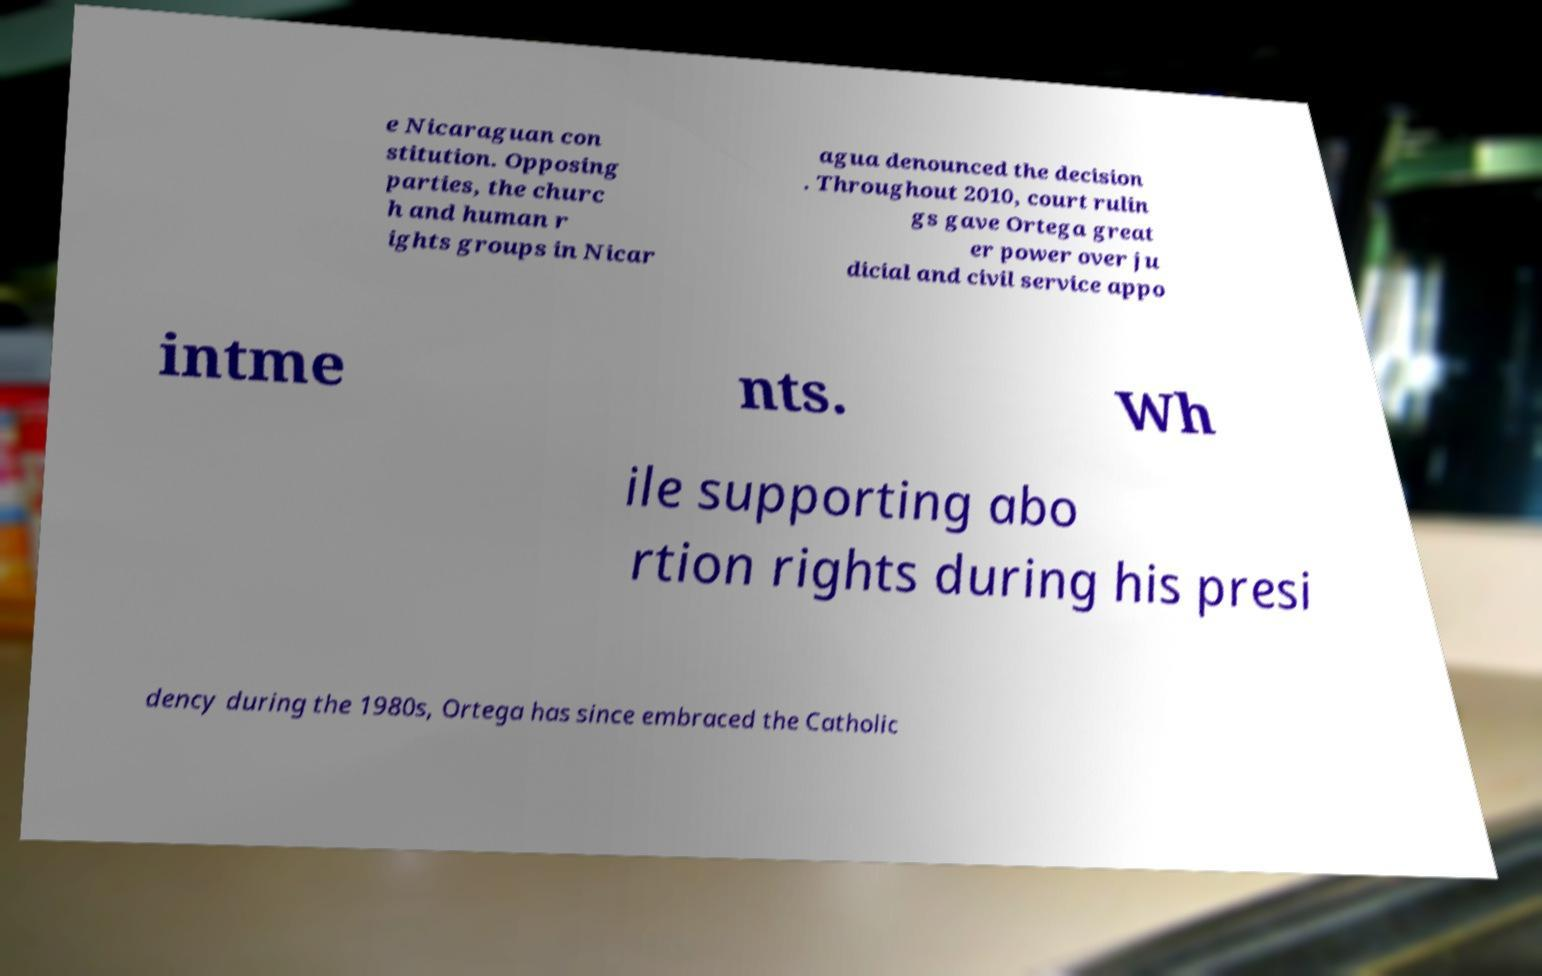For documentation purposes, I need the text within this image transcribed. Could you provide that? e Nicaraguan con stitution. Opposing parties, the churc h and human r ights groups in Nicar agua denounced the decision . Throughout 2010, court rulin gs gave Ortega great er power over ju dicial and civil service appo intme nts. Wh ile supporting abo rtion rights during his presi dency during the 1980s, Ortega has since embraced the Catholic 